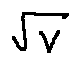Convert formula to latex. <formula><loc_0><loc_0><loc_500><loc_500>\sqrt { v }</formula> 